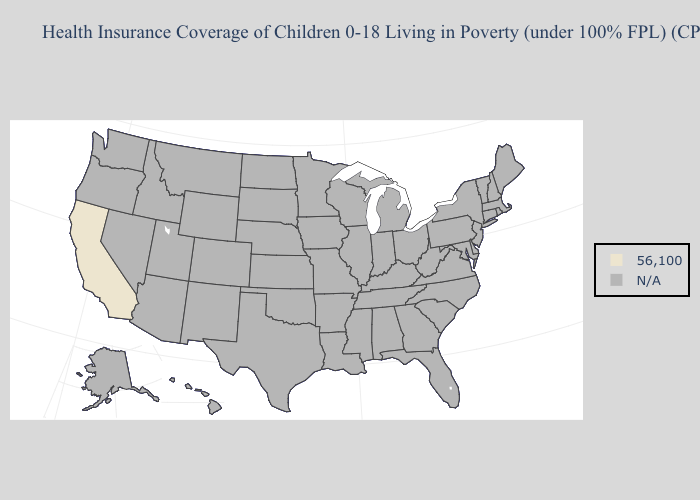Does the first symbol in the legend represent the smallest category?
Write a very short answer. No. Name the states that have a value in the range N/A?
Quick response, please. Alabama, Alaska, Arizona, Arkansas, Colorado, Connecticut, Delaware, Florida, Georgia, Hawaii, Idaho, Illinois, Indiana, Iowa, Kansas, Kentucky, Louisiana, Maine, Maryland, Massachusetts, Michigan, Minnesota, Mississippi, Missouri, Montana, Nebraska, Nevada, New Hampshire, New Jersey, New Mexico, New York, North Carolina, North Dakota, Ohio, Oklahoma, Oregon, Pennsylvania, Rhode Island, South Carolina, South Dakota, Tennessee, Texas, Utah, Vermont, Virginia, Washington, West Virginia, Wisconsin, Wyoming. Name the states that have a value in the range 56,100?
Keep it brief. California. What is the lowest value in the USA?
Concise answer only. 56,100. What is the value of Michigan?
Give a very brief answer. N/A. What is the value of Nebraska?
Quick response, please. N/A. Which states have the lowest value in the West?
Answer briefly. California. What is the value of Montana?
Short answer required. N/A. Is the legend a continuous bar?
Give a very brief answer. No. How many symbols are there in the legend?
Concise answer only. 2. What is the lowest value in states that border Arizona?
Concise answer only. 56,100. 